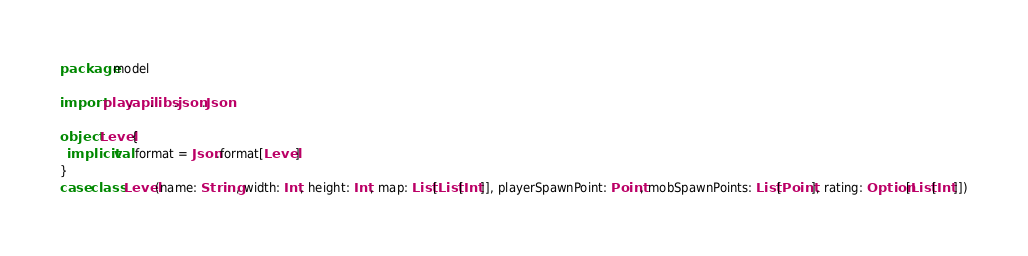<code> <loc_0><loc_0><loc_500><loc_500><_Scala_>package model

import play.api.libs.json.Json

object Level{
  implicit val format = Json.format[Level]
}
case class Level(name: String, width: Int, height: Int, map: List[List[Int]], playerSpawnPoint: Point, mobSpawnPoints: List[Point], rating: Option[List[Int]])</code> 